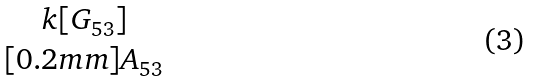<formula> <loc_0><loc_0><loc_500><loc_500>\begin{matrix} k [ G _ { 5 3 } ] \\ [ 0 . 2 m m ] A _ { 5 3 } \end{matrix}</formula> 